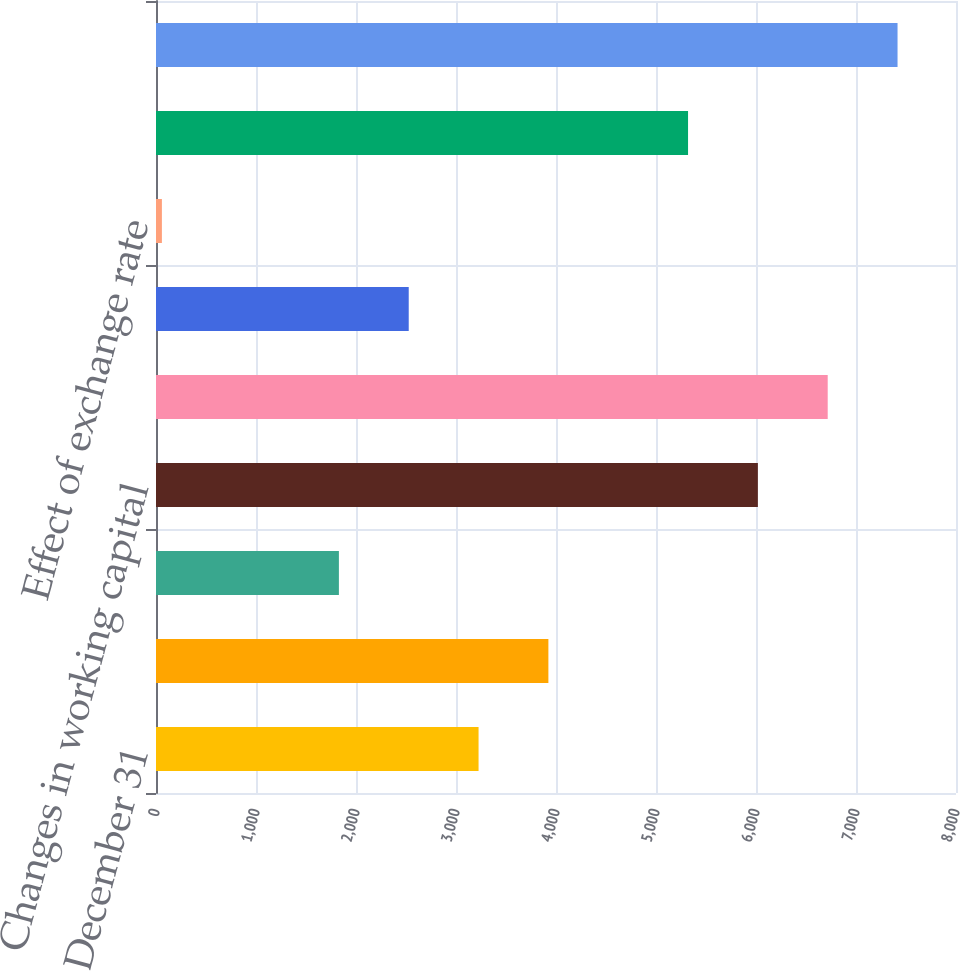Convert chart to OTSL. <chart><loc_0><loc_0><loc_500><loc_500><bar_chart><fcel>Years ended December 31<fcel>Net earnings<fcel>Non-cash items<fcel>Changes in working capital<fcel>Net cash provided/(used) by<fcel>Net cash (used)/provided by<fcel>Effect of exchange rate<fcel>Net increase/(decrease) in<fcel>Cash and cash equivalents at<nl><fcel>3225.6<fcel>3923.9<fcel>1829<fcel>6018.8<fcel>6717.1<fcel>2527.3<fcel>59<fcel>5320.5<fcel>7415.4<nl></chart> 